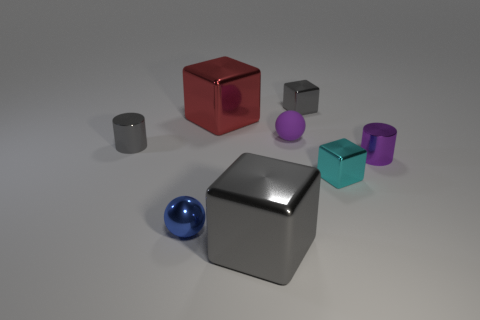Subtract all purple balls. How many gray blocks are left? 2 Subtract all tiny gray shiny cubes. How many cubes are left? 3 Add 1 yellow spheres. How many objects exist? 9 Subtract 2 cubes. How many cubes are left? 2 Subtract all cyan cubes. How many cubes are left? 3 Subtract all cylinders. How many objects are left? 6 Add 5 tiny gray cubes. How many tiny gray cubes exist? 6 Subtract 1 blue spheres. How many objects are left? 7 Subtract all purple balls. Subtract all green blocks. How many balls are left? 1 Subtract all large green rubber things. Subtract all gray shiny blocks. How many objects are left? 6 